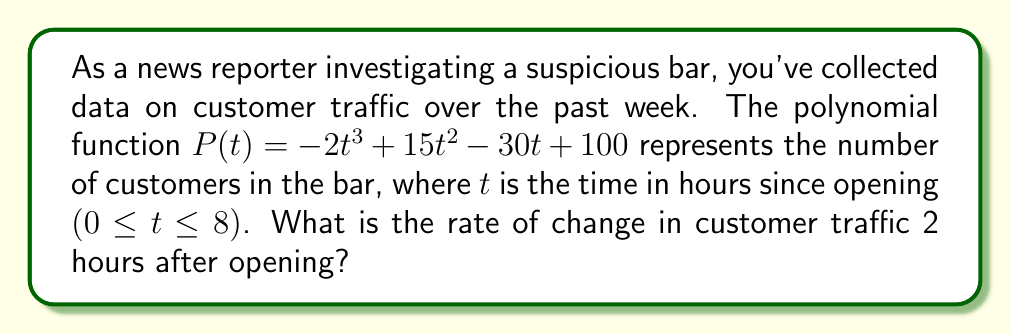What is the answer to this math problem? To find the rate of change in customer traffic at a specific time, we need to calculate the derivative of the given polynomial function and evaluate it at the given time.

1. The given polynomial function is:
   $P(t) = -2t^3 + 15t^2 - 30t + 100$

2. To find the rate of change, we need to find $P'(t)$:
   $P'(t) = \frac{d}{dt}(-2t^3 + 15t^2 - 30t + 100)$
   $P'(t) = -6t^2 + 30t - 30$

3. Now, we need to evaluate $P'(t)$ at $t = 2$ hours:
   $P'(2) = -6(2)^2 + 30(2) - 30$
   $P'(2) = -6(4) + 60 - 30$
   $P'(2) = -24 + 60 - 30$
   $P'(2) = 6$

The rate of change is positive, indicating that the number of customers is increasing 2 hours after opening.
Answer: The rate of change in customer traffic 2 hours after opening is 6 customers per hour. 